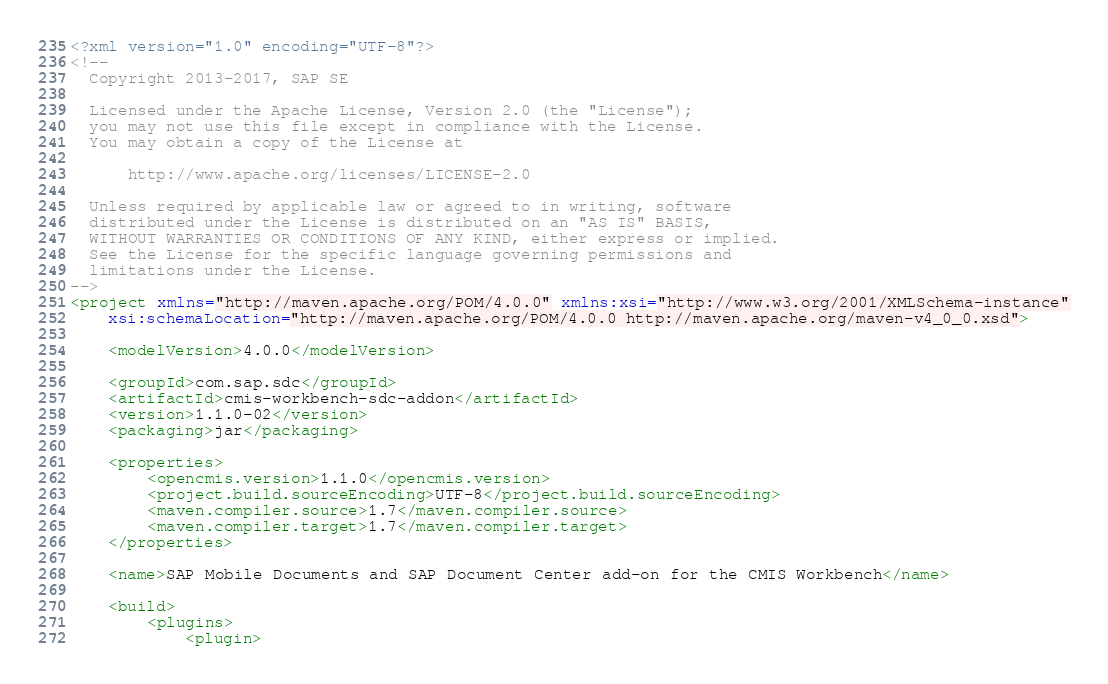<code> <loc_0><loc_0><loc_500><loc_500><_XML_><?xml version="1.0" encoding="UTF-8"?>
<!--
  Copyright 2013-2017, SAP SE 

  Licensed under the Apache License, Version 2.0 (the "License");
  you may not use this file except in compliance with the License.
  You may obtain a copy of the License at

      http://www.apache.org/licenses/LICENSE-2.0

  Unless required by applicable law or agreed to in writing, software
  distributed under the License is distributed on an "AS IS" BASIS,
  WITHOUT WARRANTIES OR CONDITIONS OF ANY KIND, either express or implied.
  See the License for the specific language governing permissions and
  limitations under the License.
-->
<project xmlns="http://maven.apache.org/POM/4.0.0" xmlns:xsi="http://www.w3.org/2001/XMLSchema-instance"
	xsi:schemaLocation="http://maven.apache.org/POM/4.0.0 http://maven.apache.org/maven-v4_0_0.xsd">

	<modelVersion>4.0.0</modelVersion>

	<groupId>com.sap.sdc</groupId>
	<artifactId>cmis-workbench-sdc-addon</artifactId>
	<version>1.1.0-02</version>
	<packaging>jar</packaging>

	<properties>
		<opencmis.version>1.1.0</opencmis.version>
		<project.build.sourceEncoding>UTF-8</project.build.sourceEncoding>
        <maven.compiler.source>1.7</maven.compiler.source>
        <maven.compiler.target>1.7</maven.compiler.target>
	</properties>

	<name>SAP Mobile Documents and SAP Document Center add-on for the CMIS Workbench</name>

	<build>
		<plugins>
			<plugin></code> 